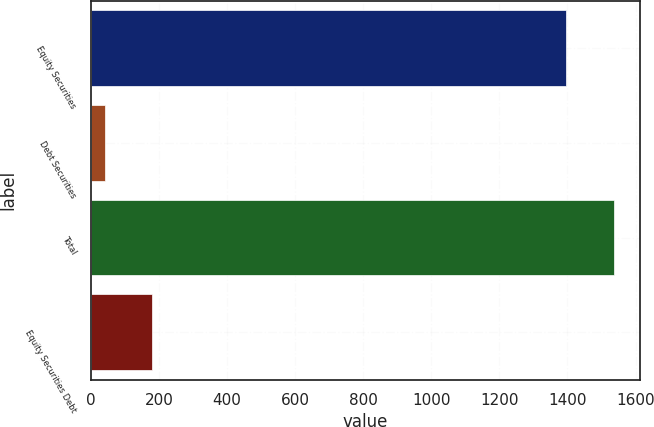Convert chart to OTSL. <chart><loc_0><loc_0><loc_500><loc_500><bar_chart><fcel>Equity Securities<fcel>Debt Securities<fcel>Total<fcel>Equity Securities Debt<nl><fcel>1396<fcel>41<fcel>1535.6<fcel>180.6<nl></chart> 